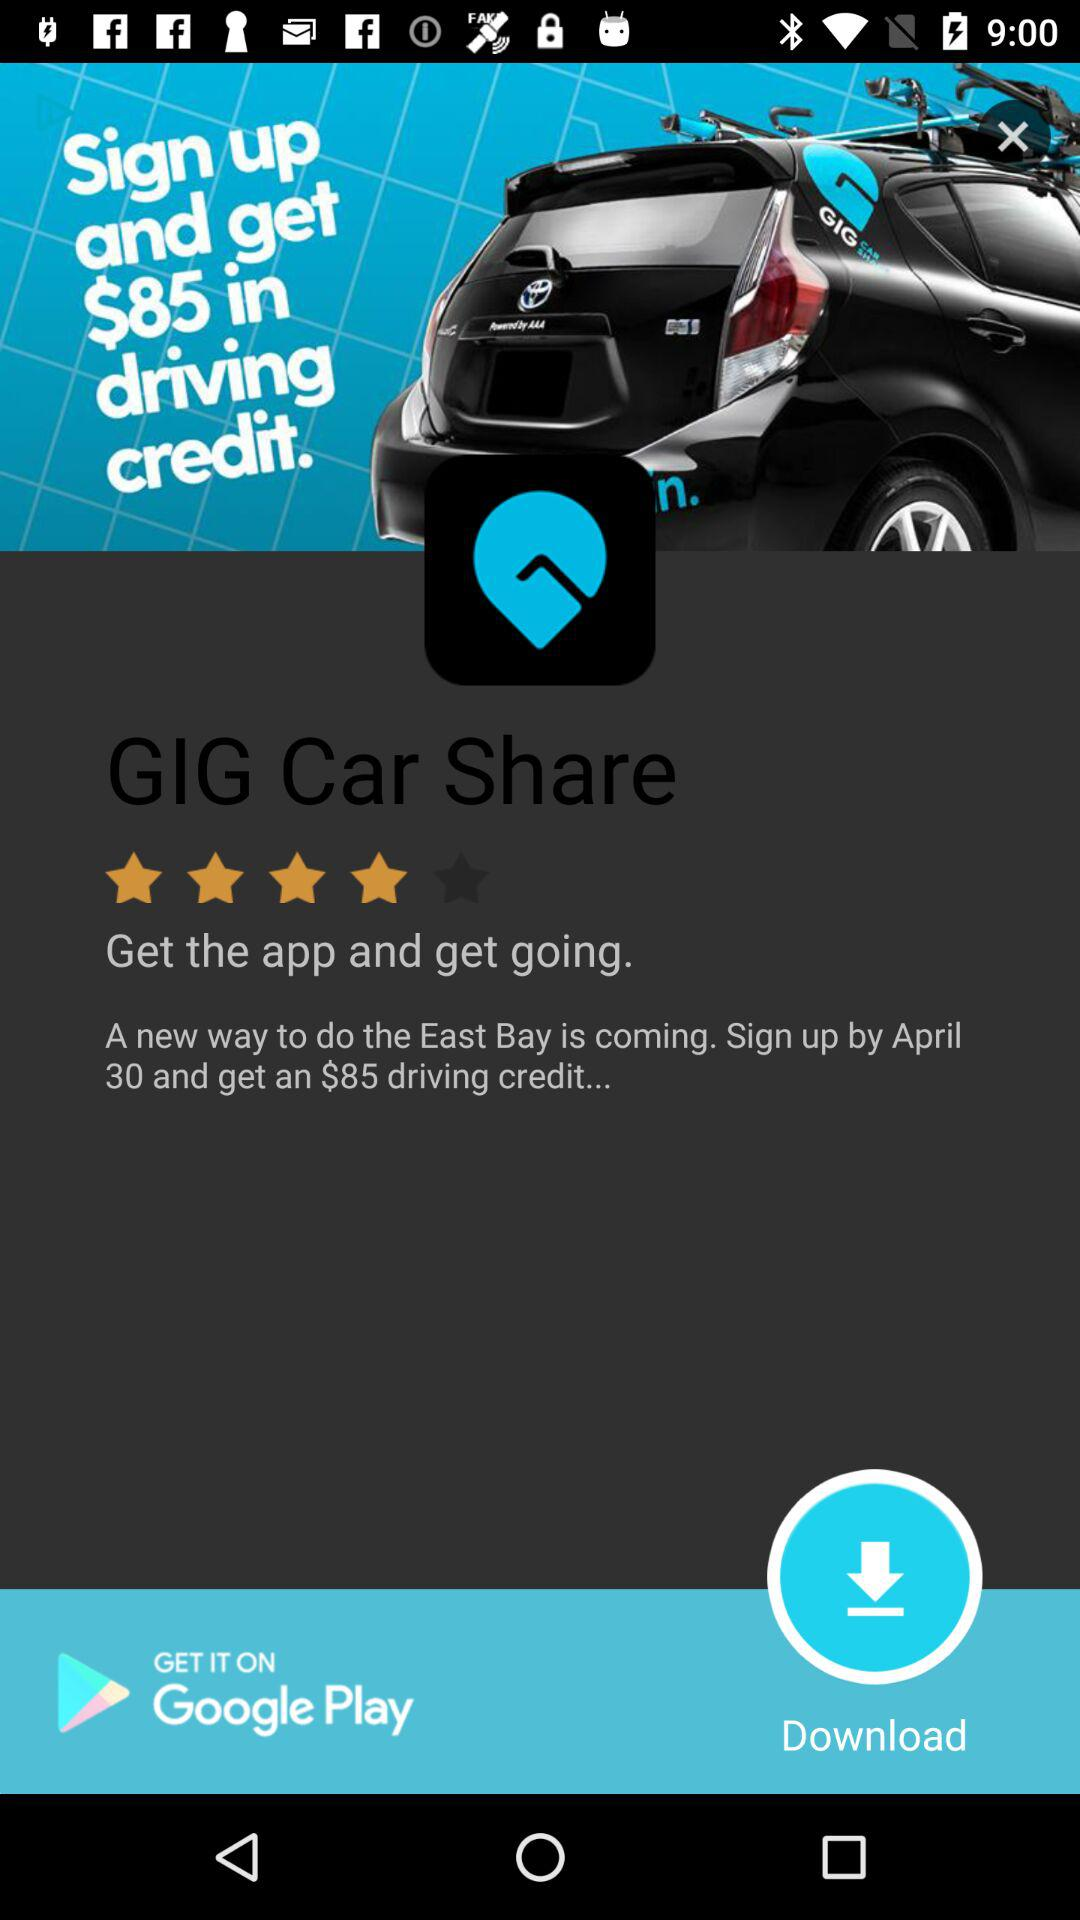What is the rating of the application? The rating is 4 stars. 